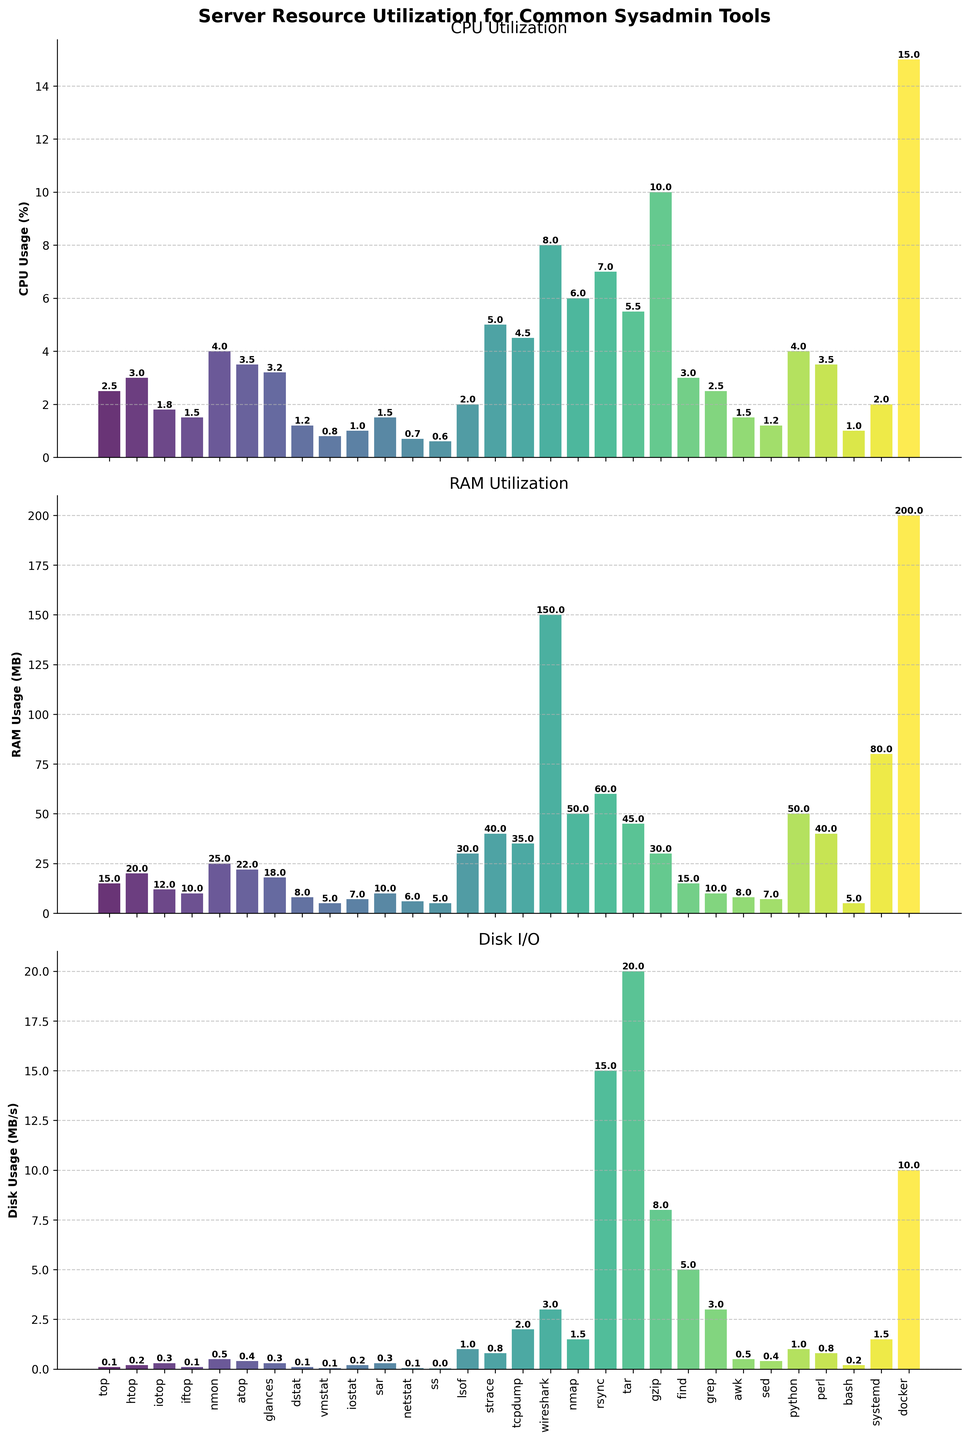Which tool/process uses the most RAM? The RAM Utilization bar chart shows that the tool/process with the highest bar in terms of RAM usage is Wireshark, which is labeled '8.0' on the Y-axis.
Answer: Wireshark Which tool/process has the lowest CPU usage? The CPU Utilization bar chart indicates that the tool/process with the lowest CPU usage is 'ss', with a CPU usage of '0.6%'
Answer: ss Between 'docker' and 'rsync', which one consumes more resources on average for CPU, RAM, and Disk? First, compute the average resource utilization for each. Docker: (15 + 200 + 10)/3 = 75; Rsync: (7 + 60 + 15)/3 = 27.67. Docker consumes more resources on average.
Answer: Docker What is the total disk I/O for 'rsync' and 'tar' combined? From the Disk I/O bar chart, rsync uses '15.0 MB/s' and tar uses '20.0 MB/s'. Adding these gives 15.0 + 20.0 = 35.0 MB/s.
Answer: 35.0 MB/s Which has greater range in RAM usage, 'htop' or 'sar'? The RAM utilization for 'htop' is 20 MB and for 'sar' is 10 MB. The range is calculated as max - min. Range for 'htop' is 20, and for 'sar' is 10. So, 'htop' has a greater range.
Answer: htop Among 'awk', 'sed', and 'grep', which tool/process uses the most disk I/O? Refer to the Disk I/O bar chart: grep uses '3.0 MB/s', awk uses '0.5 MB/s', and sed uses '0.4 MB/s'. The highest usage among them is 'grep'.
Answer: grep What's the average CPU usage of 'iotop', 'iftop', and 'nmon'? Sum the CPU usages of 'iotop' (1.8), 'iftop' (1.5), and 'nmon' (4.0), then divide by 3. (1.8 + 1.5 + 4.0) / 3 = 7.3 / 3 = 2.43.
Answer: 2.43 Which tool/process has the most balanced resource usage across CPU, RAM, and Disk? balance is indicated by the most similar heights for CPU, RAM, and Disk in each category. 'glances' uses CPU: 3.2%, RAM: 18 MB, Disk: 0.3 MB/s. Each category has similarly moderate usage values compared to others.
Answer: glances What is the approximate combined CPU usage of all the listed tools/processes? Sum all the CPU usage percentages from the CPU Utilization bar chart. 2.5 + 3.0 + 1.8 + 1.5 + 4.0 + 3.5 + 3.2 + 1.2 + 0.8 + 1.0 + 1.5 + 0.7 + 0.6 + 2.0 + 5.0 + 4.5 + 8.0 + 6.0 + 7.0 + 5.5 + 10.0 + 3.0 + 2.5 + 1.5 + 1.2 + 4.0 + 3.5 + 1.0 + 2.0 + 15.0 = 110.6.
Answer: Approx. 110.6 